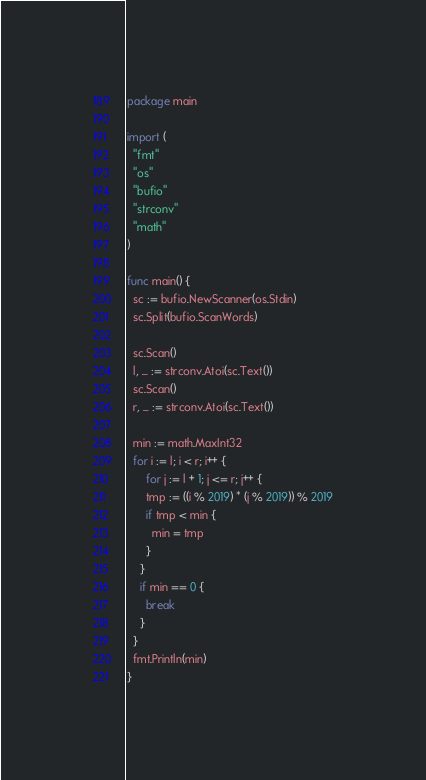<code> <loc_0><loc_0><loc_500><loc_500><_Go_>package main

import (
  "fmt"
  "os"
  "bufio"
  "strconv"
  "math"
)

func main() {
  sc := bufio.NewScanner(os.Stdin)
  sc.Split(bufio.ScanWords)

  sc.Scan()
  l, _ := strconv.Atoi(sc.Text())
  sc.Scan()
  r, _ := strconv.Atoi(sc.Text())

  min := math.MaxInt32
  for i := l; i < r; i++ {
      for j := l + 1; j <= r; j++ {
      tmp := ((i % 2019) * (j % 2019)) % 2019
      if tmp < min {
        min = tmp
      }
    }
    if min == 0 {
      break
    }
  }
  fmt.Println(min)
}

</code> 